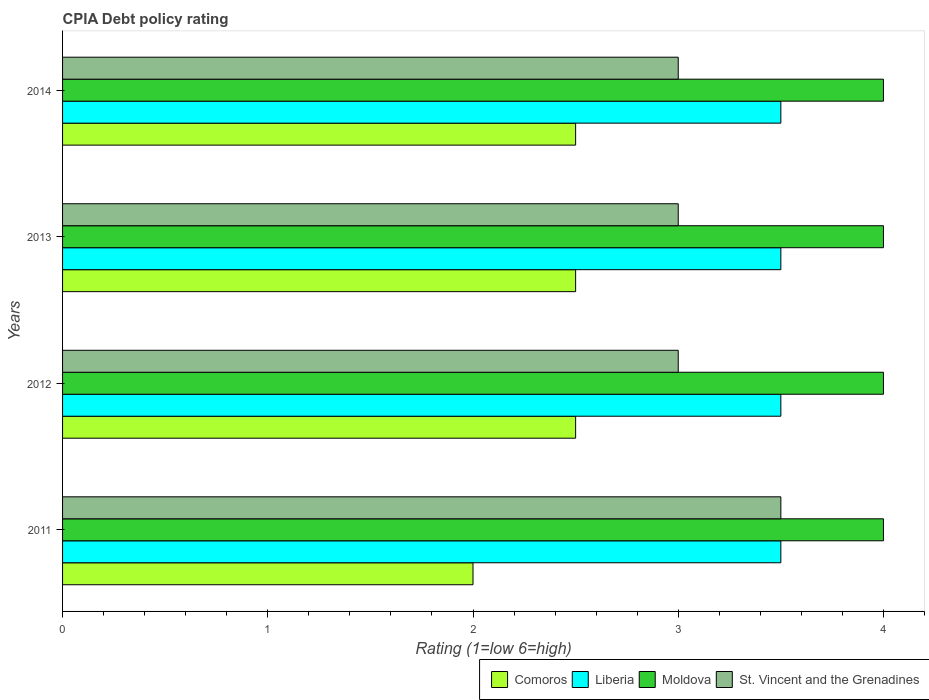How many bars are there on the 3rd tick from the top?
Give a very brief answer. 4. What is the label of the 1st group of bars from the top?
Provide a short and direct response. 2014. In how many cases, is the number of bars for a given year not equal to the number of legend labels?
Provide a short and direct response. 0. What is the CPIA rating in St. Vincent and the Grenadines in 2013?
Keep it short and to the point. 3. Across all years, what is the maximum CPIA rating in Liberia?
Ensure brevity in your answer.  3.5. Across all years, what is the minimum CPIA rating in Comoros?
Your answer should be compact. 2. In which year was the CPIA rating in St. Vincent and the Grenadines minimum?
Give a very brief answer. 2012. What is the average CPIA rating in St. Vincent and the Grenadines per year?
Your answer should be compact. 3.12. In the year 2014, what is the difference between the CPIA rating in Liberia and CPIA rating in Comoros?
Your answer should be very brief. 1. What is the difference between the highest and the second highest CPIA rating in Comoros?
Provide a succinct answer. 0. What is the difference between the highest and the lowest CPIA rating in Comoros?
Your response must be concise. 0.5. In how many years, is the CPIA rating in Liberia greater than the average CPIA rating in Liberia taken over all years?
Keep it short and to the point. 0. Is it the case that in every year, the sum of the CPIA rating in Comoros and CPIA rating in St. Vincent and the Grenadines is greater than the sum of CPIA rating in Liberia and CPIA rating in Moldova?
Keep it short and to the point. Yes. What does the 3rd bar from the top in 2012 represents?
Your answer should be compact. Liberia. What does the 4th bar from the bottom in 2014 represents?
Give a very brief answer. St. Vincent and the Grenadines. How are the legend labels stacked?
Offer a very short reply. Horizontal. What is the title of the graph?
Your answer should be very brief. CPIA Debt policy rating. Does "Guatemala" appear as one of the legend labels in the graph?
Offer a very short reply. No. What is the label or title of the X-axis?
Offer a terse response. Rating (1=low 6=high). What is the label or title of the Y-axis?
Keep it short and to the point. Years. What is the Rating (1=low 6=high) in Comoros in 2011?
Give a very brief answer. 2. What is the Rating (1=low 6=high) in Liberia in 2011?
Make the answer very short. 3.5. What is the Rating (1=low 6=high) of Moldova in 2011?
Your answer should be very brief. 4. What is the Rating (1=low 6=high) of St. Vincent and the Grenadines in 2011?
Offer a very short reply. 3.5. What is the Rating (1=low 6=high) of Moldova in 2012?
Provide a succinct answer. 4. What is the Rating (1=low 6=high) in St. Vincent and the Grenadines in 2013?
Your answer should be compact. 3. What is the Rating (1=low 6=high) in Comoros in 2014?
Ensure brevity in your answer.  2.5. What is the Rating (1=low 6=high) in Liberia in 2014?
Your answer should be compact. 3.5. What is the Rating (1=low 6=high) in Moldova in 2014?
Make the answer very short. 4. What is the Rating (1=low 6=high) of St. Vincent and the Grenadines in 2014?
Your response must be concise. 3. Across all years, what is the maximum Rating (1=low 6=high) in Comoros?
Your response must be concise. 2.5. Across all years, what is the maximum Rating (1=low 6=high) of Moldova?
Ensure brevity in your answer.  4. Across all years, what is the minimum Rating (1=low 6=high) of Liberia?
Provide a succinct answer. 3.5. Across all years, what is the minimum Rating (1=low 6=high) of Moldova?
Your response must be concise. 4. What is the total Rating (1=low 6=high) of Comoros in the graph?
Your answer should be compact. 9.5. What is the total Rating (1=low 6=high) in Moldova in the graph?
Your response must be concise. 16. What is the total Rating (1=low 6=high) of St. Vincent and the Grenadines in the graph?
Offer a very short reply. 12.5. What is the difference between the Rating (1=low 6=high) in Comoros in 2011 and that in 2012?
Keep it short and to the point. -0.5. What is the difference between the Rating (1=low 6=high) of St. Vincent and the Grenadines in 2011 and that in 2012?
Ensure brevity in your answer.  0.5. What is the difference between the Rating (1=low 6=high) in Comoros in 2011 and that in 2013?
Offer a very short reply. -0.5. What is the difference between the Rating (1=low 6=high) of Liberia in 2011 and that in 2013?
Offer a very short reply. 0. What is the difference between the Rating (1=low 6=high) in Moldova in 2011 and that in 2013?
Ensure brevity in your answer.  0. What is the difference between the Rating (1=low 6=high) of St. Vincent and the Grenadines in 2011 and that in 2013?
Your answer should be compact. 0.5. What is the difference between the Rating (1=low 6=high) in Comoros in 2011 and that in 2014?
Make the answer very short. -0.5. What is the difference between the Rating (1=low 6=high) of Comoros in 2012 and that in 2013?
Provide a short and direct response. 0. What is the difference between the Rating (1=low 6=high) of St. Vincent and the Grenadines in 2012 and that in 2013?
Keep it short and to the point. 0. What is the difference between the Rating (1=low 6=high) in Comoros in 2012 and that in 2014?
Provide a succinct answer. 0. What is the difference between the Rating (1=low 6=high) of Moldova in 2012 and that in 2014?
Offer a very short reply. 0. What is the difference between the Rating (1=low 6=high) of St. Vincent and the Grenadines in 2012 and that in 2014?
Your answer should be compact. 0. What is the difference between the Rating (1=low 6=high) in St. Vincent and the Grenadines in 2013 and that in 2014?
Give a very brief answer. 0. What is the difference between the Rating (1=low 6=high) in Comoros in 2011 and the Rating (1=low 6=high) in Liberia in 2012?
Your answer should be compact. -1.5. What is the difference between the Rating (1=low 6=high) of Comoros in 2011 and the Rating (1=low 6=high) of Moldova in 2012?
Your response must be concise. -2. What is the difference between the Rating (1=low 6=high) in Liberia in 2011 and the Rating (1=low 6=high) in St. Vincent and the Grenadines in 2012?
Offer a terse response. 0.5. What is the difference between the Rating (1=low 6=high) in Comoros in 2011 and the Rating (1=low 6=high) in Liberia in 2013?
Provide a short and direct response. -1.5. What is the difference between the Rating (1=low 6=high) of Comoros in 2011 and the Rating (1=low 6=high) of Moldova in 2013?
Provide a short and direct response. -2. What is the difference between the Rating (1=low 6=high) in Comoros in 2011 and the Rating (1=low 6=high) in St. Vincent and the Grenadines in 2013?
Ensure brevity in your answer.  -1. What is the difference between the Rating (1=low 6=high) in Liberia in 2011 and the Rating (1=low 6=high) in Moldova in 2014?
Your answer should be very brief. -0.5. What is the difference between the Rating (1=low 6=high) of Liberia in 2011 and the Rating (1=low 6=high) of St. Vincent and the Grenadines in 2014?
Provide a succinct answer. 0.5. What is the difference between the Rating (1=low 6=high) in Comoros in 2012 and the Rating (1=low 6=high) in Liberia in 2013?
Offer a very short reply. -1. What is the difference between the Rating (1=low 6=high) of Comoros in 2012 and the Rating (1=low 6=high) of Moldova in 2013?
Provide a succinct answer. -1.5. What is the difference between the Rating (1=low 6=high) in Moldova in 2012 and the Rating (1=low 6=high) in St. Vincent and the Grenadines in 2013?
Your response must be concise. 1. What is the difference between the Rating (1=low 6=high) in Comoros in 2012 and the Rating (1=low 6=high) in St. Vincent and the Grenadines in 2014?
Give a very brief answer. -0.5. What is the difference between the Rating (1=low 6=high) in Liberia in 2012 and the Rating (1=low 6=high) in St. Vincent and the Grenadines in 2014?
Your answer should be compact. 0.5. What is the difference between the Rating (1=low 6=high) of Moldova in 2012 and the Rating (1=low 6=high) of St. Vincent and the Grenadines in 2014?
Keep it short and to the point. 1. What is the difference between the Rating (1=low 6=high) of Comoros in 2013 and the Rating (1=low 6=high) of Liberia in 2014?
Give a very brief answer. -1. What is the difference between the Rating (1=low 6=high) in Comoros in 2013 and the Rating (1=low 6=high) in Moldova in 2014?
Provide a succinct answer. -1.5. What is the difference between the Rating (1=low 6=high) in Comoros in 2013 and the Rating (1=low 6=high) in St. Vincent and the Grenadines in 2014?
Your response must be concise. -0.5. What is the difference between the Rating (1=low 6=high) in Liberia in 2013 and the Rating (1=low 6=high) in St. Vincent and the Grenadines in 2014?
Your answer should be very brief. 0.5. What is the average Rating (1=low 6=high) of Comoros per year?
Provide a short and direct response. 2.38. What is the average Rating (1=low 6=high) of Liberia per year?
Offer a very short reply. 3.5. What is the average Rating (1=low 6=high) in St. Vincent and the Grenadines per year?
Provide a succinct answer. 3.12. In the year 2011, what is the difference between the Rating (1=low 6=high) of Comoros and Rating (1=low 6=high) of St. Vincent and the Grenadines?
Your answer should be very brief. -1.5. In the year 2011, what is the difference between the Rating (1=low 6=high) in Liberia and Rating (1=low 6=high) in Moldova?
Offer a very short reply. -0.5. In the year 2011, what is the difference between the Rating (1=low 6=high) of Liberia and Rating (1=low 6=high) of St. Vincent and the Grenadines?
Provide a short and direct response. 0. In the year 2012, what is the difference between the Rating (1=low 6=high) in Comoros and Rating (1=low 6=high) in Moldova?
Make the answer very short. -1.5. In the year 2012, what is the difference between the Rating (1=low 6=high) of Liberia and Rating (1=low 6=high) of Moldova?
Make the answer very short. -0.5. In the year 2012, what is the difference between the Rating (1=low 6=high) in Liberia and Rating (1=low 6=high) in St. Vincent and the Grenadines?
Make the answer very short. 0.5. In the year 2012, what is the difference between the Rating (1=low 6=high) in Moldova and Rating (1=low 6=high) in St. Vincent and the Grenadines?
Keep it short and to the point. 1. In the year 2013, what is the difference between the Rating (1=low 6=high) of Comoros and Rating (1=low 6=high) of Liberia?
Your response must be concise. -1. In the year 2013, what is the difference between the Rating (1=low 6=high) in Liberia and Rating (1=low 6=high) in Moldova?
Keep it short and to the point. -0.5. In the year 2013, what is the difference between the Rating (1=low 6=high) of Moldova and Rating (1=low 6=high) of St. Vincent and the Grenadines?
Give a very brief answer. 1. In the year 2014, what is the difference between the Rating (1=low 6=high) of Comoros and Rating (1=low 6=high) of Liberia?
Provide a short and direct response. -1. In the year 2014, what is the difference between the Rating (1=low 6=high) in Liberia and Rating (1=low 6=high) in Moldova?
Offer a very short reply. -0.5. What is the ratio of the Rating (1=low 6=high) of Liberia in 2011 to that in 2012?
Provide a short and direct response. 1. What is the ratio of the Rating (1=low 6=high) in Comoros in 2011 to that in 2013?
Make the answer very short. 0.8. What is the ratio of the Rating (1=low 6=high) in Moldova in 2011 to that in 2013?
Provide a short and direct response. 1. What is the ratio of the Rating (1=low 6=high) in Liberia in 2011 to that in 2014?
Provide a succinct answer. 1. What is the ratio of the Rating (1=low 6=high) of St. Vincent and the Grenadines in 2011 to that in 2014?
Keep it short and to the point. 1.17. What is the ratio of the Rating (1=low 6=high) in Comoros in 2012 to that in 2013?
Make the answer very short. 1. What is the ratio of the Rating (1=low 6=high) of Liberia in 2012 to that in 2013?
Offer a terse response. 1. What is the ratio of the Rating (1=low 6=high) of St. Vincent and the Grenadines in 2012 to that in 2013?
Your response must be concise. 1. What is the ratio of the Rating (1=low 6=high) in Liberia in 2012 to that in 2014?
Give a very brief answer. 1. What is the ratio of the Rating (1=low 6=high) in Liberia in 2013 to that in 2014?
Your answer should be compact. 1. What is the ratio of the Rating (1=low 6=high) of St. Vincent and the Grenadines in 2013 to that in 2014?
Provide a short and direct response. 1. What is the difference between the highest and the second highest Rating (1=low 6=high) in Comoros?
Make the answer very short. 0. What is the difference between the highest and the second highest Rating (1=low 6=high) of Moldova?
Provide a succinct answer. 0. What is the difference between the highest and the second highest Rating (1=low 6=high) of St. Vincent and the Grenadines?
Offer a terse response. 0.5. What is the difference between the highest and the lowest Rating (1=low 6=high) of Comoros?
Keep it short and to the point. 0.5. What is the difference between the highest and the lowest Rating (1=low 6=high) of Liberia?
Offer a very short reply. 0. What is the difference between the highest and the lowest Rating (1=low 6=high) in Moldova?
Make the answer very short. 0. What is the difference between the highest and the lowest Rating (1=low 6=high) of St. Vincent and the Grenadines?
Give a very brief answer. 0.5. 